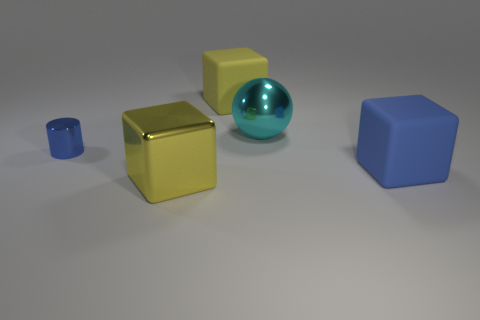Subtract all large rubber cubes. How many cubes are left? 1 Add 2 small green matte cubes. How many objects exist? 7 Subtract 1 cubes. How many cubes are left? 2 Subtract all blocks. How many objects are left? 2 Add 3 cyan things. How many cyan things are left? 4 Add 2 large spheres. How many large spheres exist? 3 Subtract 0 gray blocks. How many objects are left? 5 Subtract all tiny purple rubber things. Subtract all small blue shiny cylinders. How many objects are left? 4 